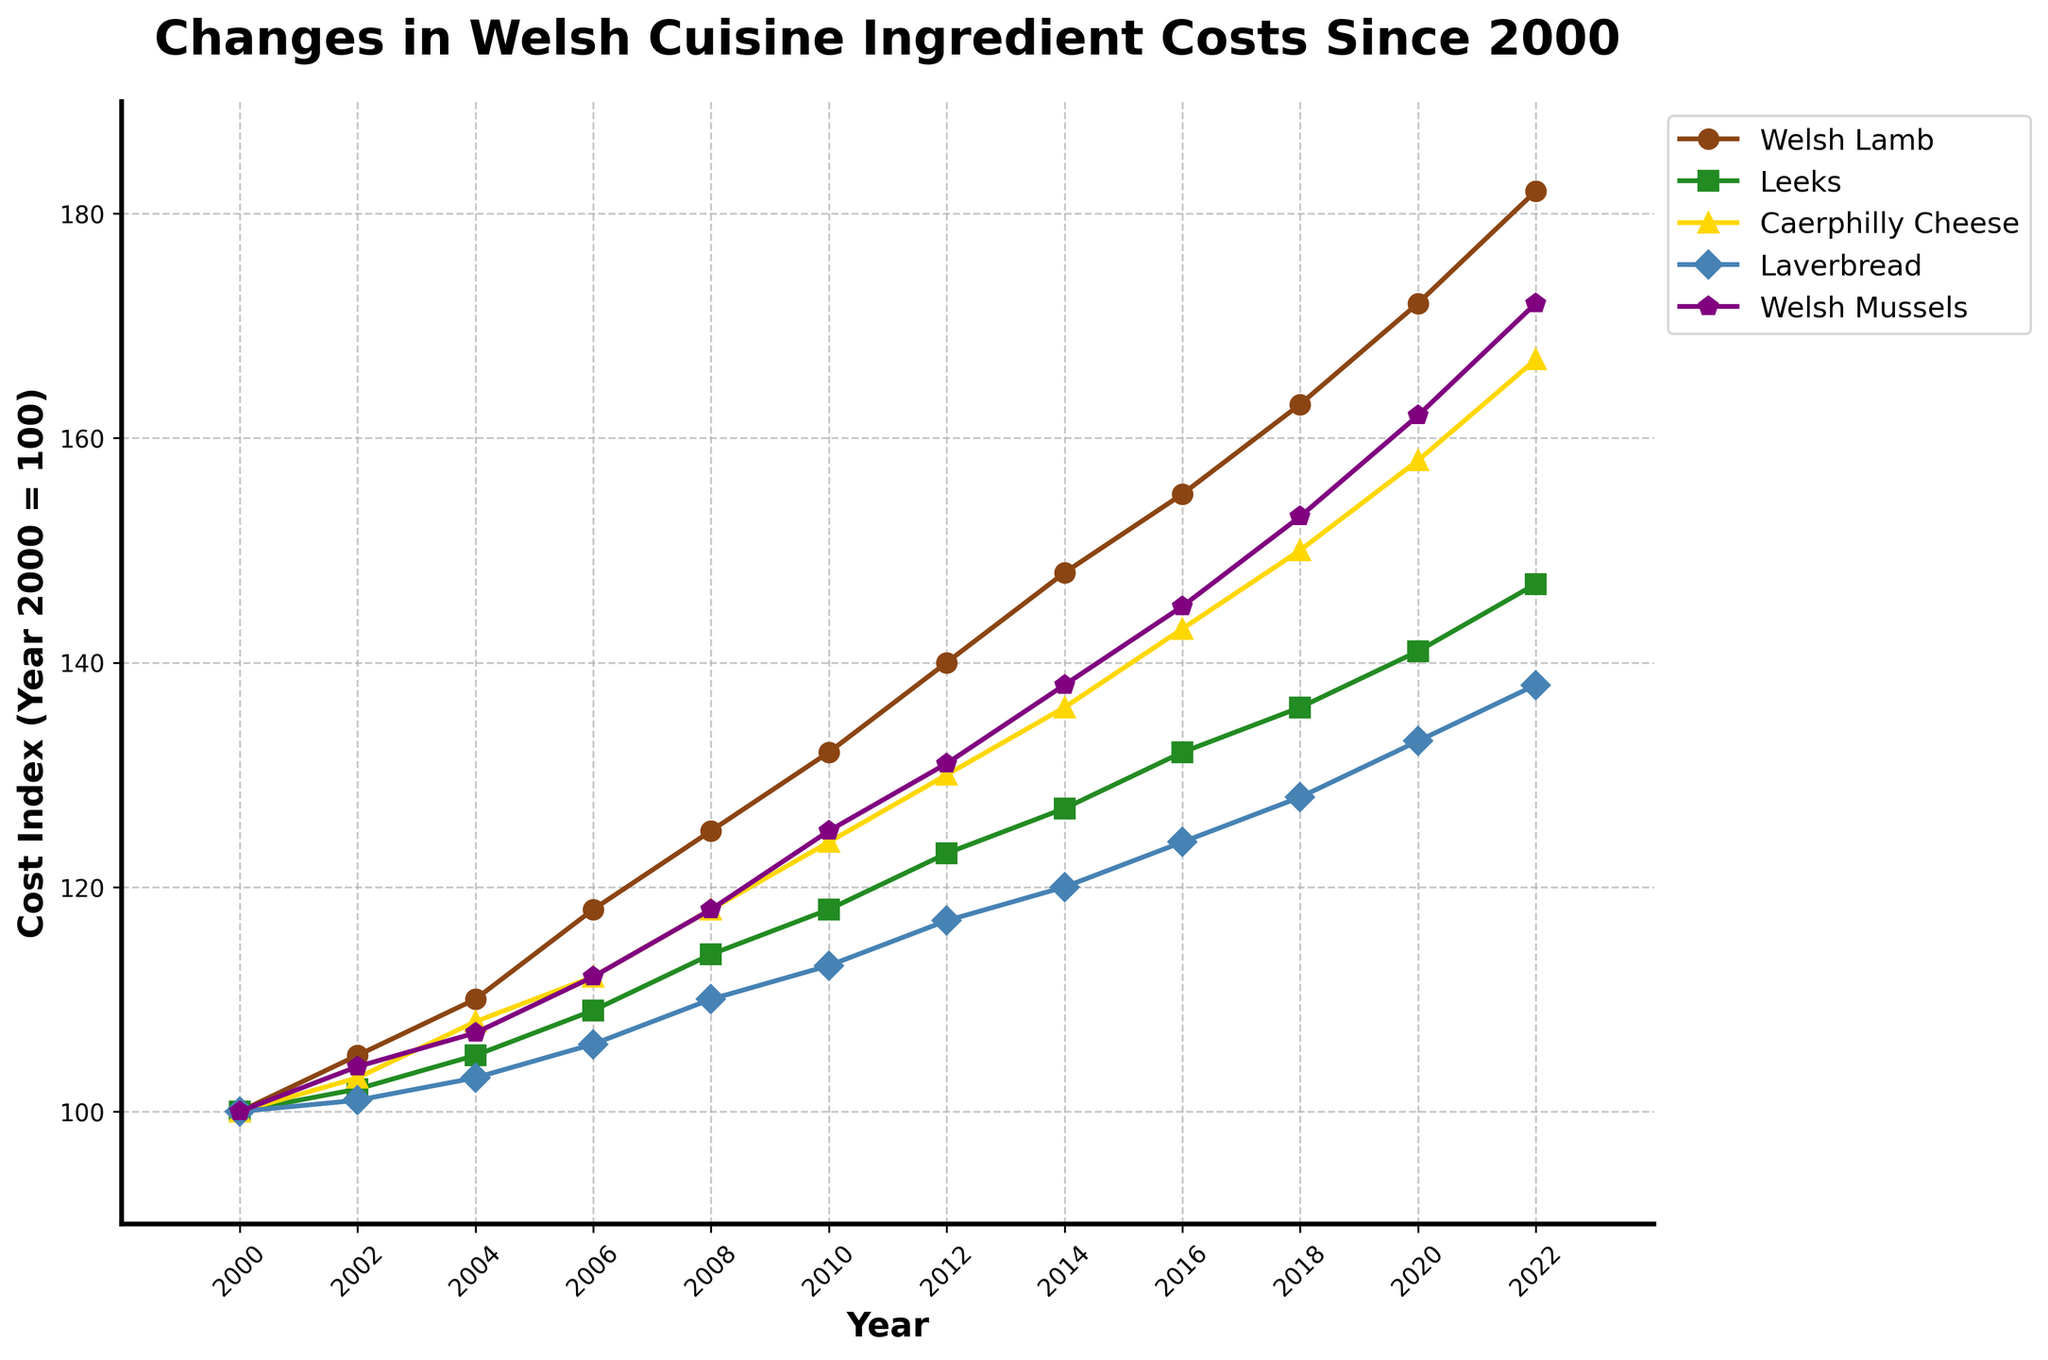What was the cost index for Welsh Lamb in 2008? Look at the data point for Welsh Lamb in 2008 on the line chart, which is represented by the brown line with circle markers. The value on the y-axis at this point is 125
Answer: 125 Which ingredient had the highest cost increase from 2000 to 2022? Compare the 2022 cost index with the 2000 cost index for each ingredient. Welsh Lamb increased from 100 to 182, Leeks from 100 to 147, Caerphilly Cheese from 100 to 167, Laverbread from 100 to 138, and Welsh Mussels from 100 to 172. The highest increase is for Welsh Lamb with an 82-point increase
Answer: Welsh Lamb By how much did the cost index for Leeks change from 2008 to 2014? Look at the cost index for Leeks in 2008 and 2014. In 2008, it's 114, and in 2014, it's 127. Calculate the difference: 127 - 114 = 13
Answer: 13 What is the cost index for Caerphilly Cheese in 2016? Refer to the data point for Caerphilly Cheese in 2016 on the line chart. The data point, represented by the gold line with triangle markers, is at the value of 143 on the y-axis
Answer: 143 Which ingredient has the most consistent increase in costs over the years? Analyze the slope and smoothness of each line. The ingredient with the most consistent increase will have a line without large fluctuations. Welsh Lamb, represented by the brown line, shows a consistent increase with a steady slope
Answer: Welsh Lamb How much more expensive was Welsh Lamb compared to Laverbread in 2020? Find the cost index for Welsh Lamb in 2020 (172) and for Laverbread in 2020 (133). Subtract the Laverbread value from the Welsh Lamb value: 172 - 133 = 39
Answer: 39 What year did Welsh Mussels surpass a cost index of 150? Look at the line for Welsh Mussels, represented by purple pentagon markers. The cost index surpasses 150 between 2016 and 2018, and in 2018, it is 153, the first value above 150
Answer: 2018 Which two ingredients had the closest cost index in 2010? Compare the values for 2010: Welsh Lamb (132), Leeks (118), Caerphilly Cheese (124), Laverbread (113), Welsh Mussels (125). The closest values are Caerphilly Cheese and Welsh Mussels, with 124 and 125 respectively
Answer: Caerphilly Cheese and Welsh Mussels How did the cost index of Laverbread change between 2004 and 2012? Calculate the percentage increase. The cost index for Laverbread in 2004 is 103 and in 2012 is 117. Calculate the percentage increase: ((117 - 103) / 103) * 100 ≈ 13.6%
Answer: 13.6% 